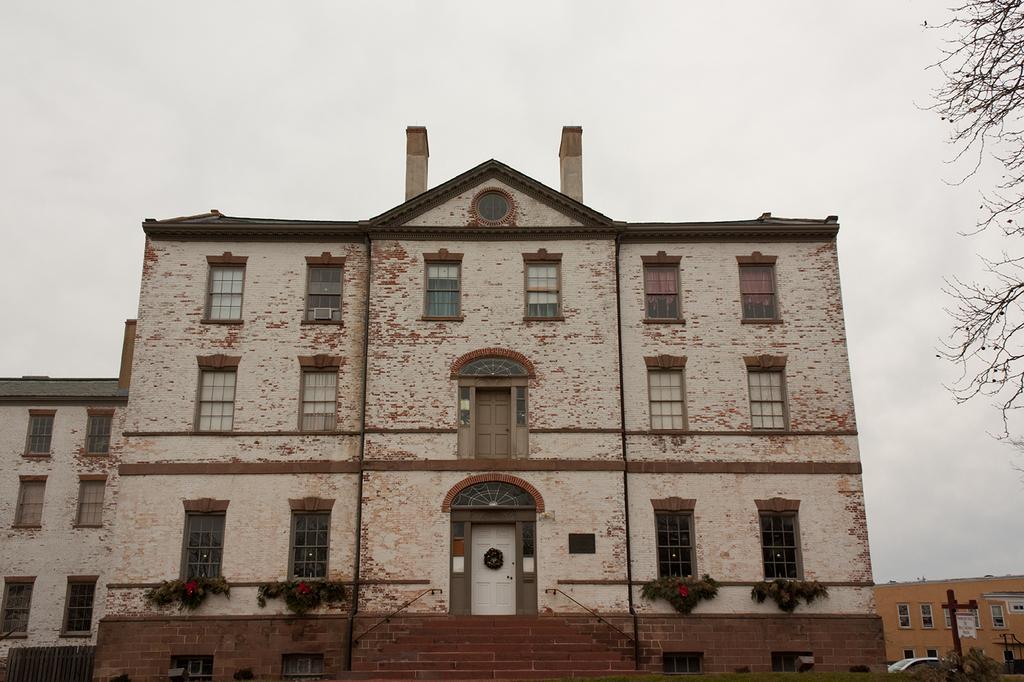Please provide a concise description of this image. In the center of the image we can see some buildings, plants, window, door are present. At the top of the image sky is there. On the right side of the image we can see a tree, poles, car, ground are there. 